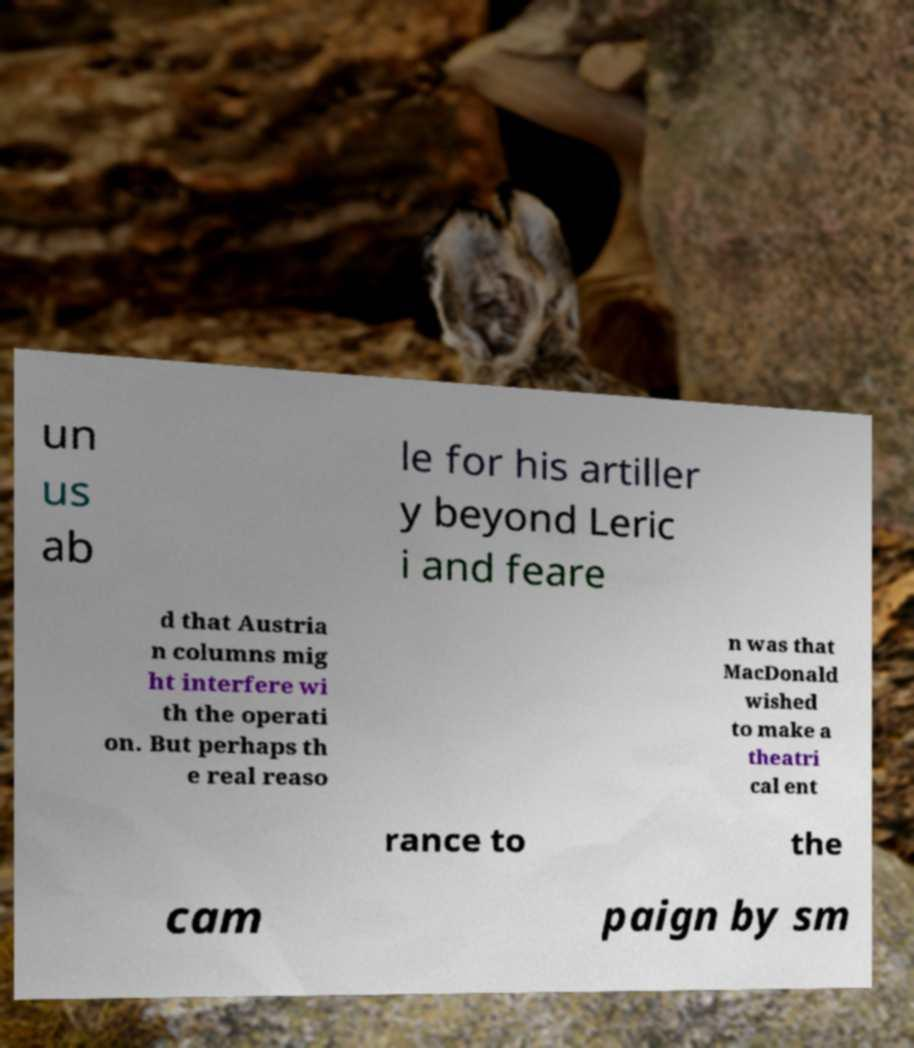Please identify and transcribe the text found in this image. un us ab le for his artiller y beyond Leric i and feare d that Austria n columns mig ht interfere wi th the operati on. But perhaps th e real reaso n was that MacDonald wished to make a theatri cal ent rance to the cam paign by sm 